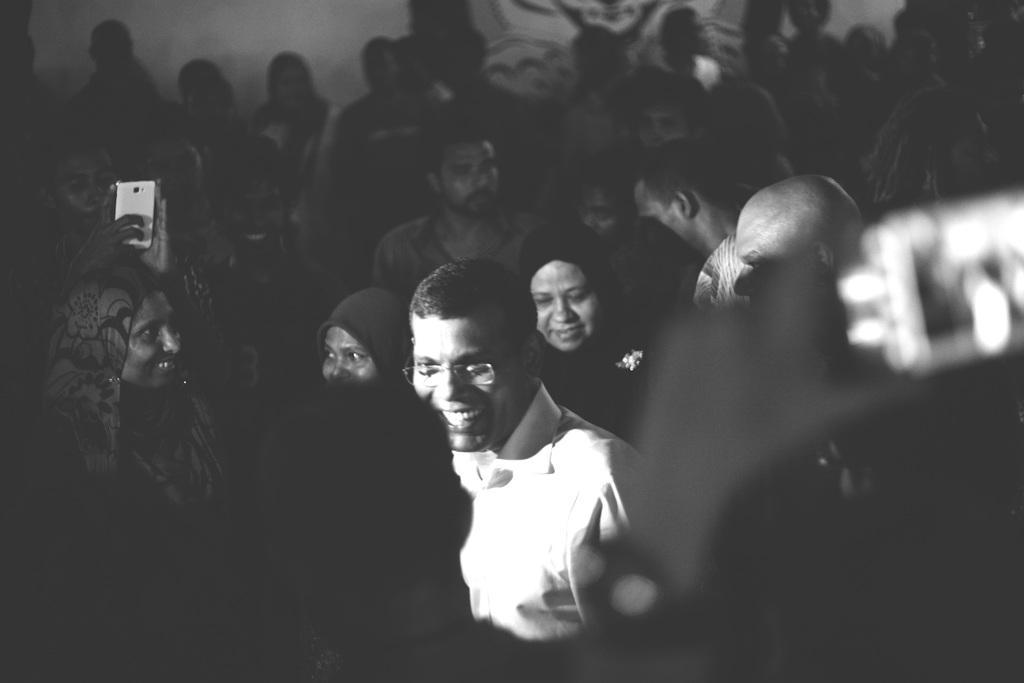In one or two sentences, can you explain what this image depicts? This is a black and white image. In the center of the image there is a person wearing a white color shirt and spectacles. There are many people around him. 